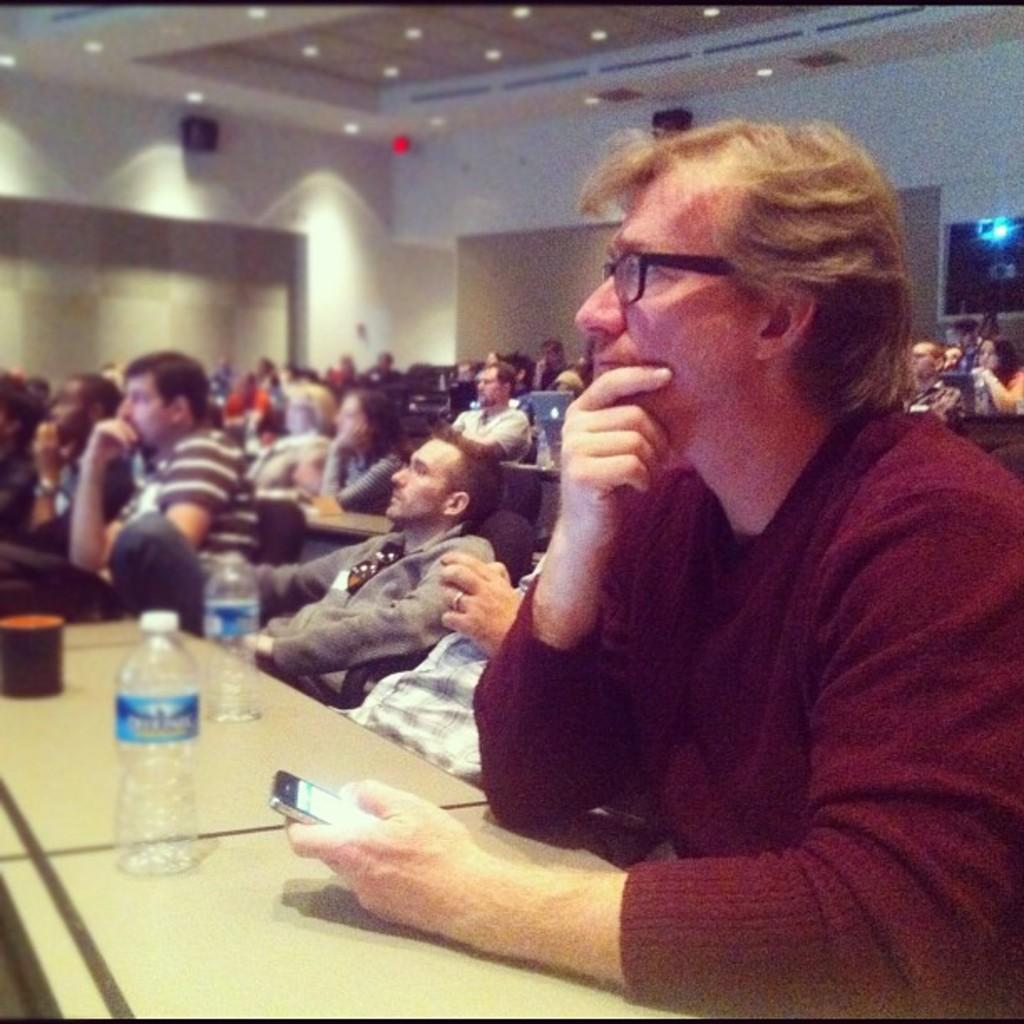What are the people in the image doing? There are people sitting in the image. What objects can be seen on the desk? There are bottles on the desk. What is a person holding in the image? A person is holding a phone. What can be seen on the roof in the image? There are lights on the roof. What type of stone is being used by the carpenter in the image? There is no carpenter or stone present in the image. 